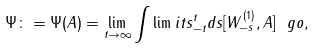Convert formula to latex. <formula><loc_0><loc_0><loc_500><loc_500>\Psi \colon = \Psi ( A ) = \lim _ { t \to \infty } \int \lim i t s _ { - t } ^ { t } d s [ W ^ { ( 1 ) } _ { - s } , A ] \ g o ,</formula> 